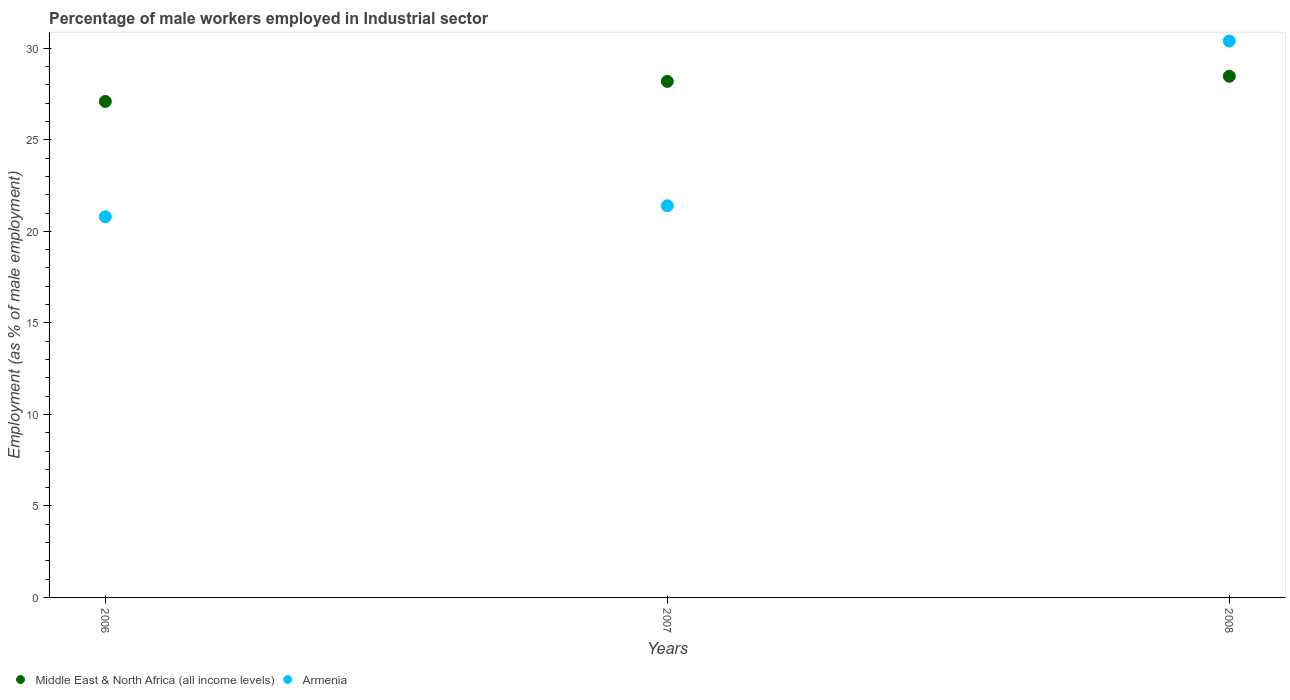What is the percentage of male workers employed in Industrial sector in Middle East & North Africa (all income levels) in 2006?
Provide a short and direct response. 27.1. Across all years, what is the maximum percentage of male workers employed in Industrial sector in Middle East & North Africa (all income levels)?
Your response must be concise. 28.47. Across all years, what is the minimum percentage of male workers employed in Industrial sector in Middle East & North Africa (all income levels)?
Provide a succinct answer. 27.1. In which year was the percentage of male workers employed in Industrial sector in Armenia maximum?
Ensure brevity in your answer.  2008. In which year was the percentage of male workers employed in Industrial sector in Armenia minimum?
Provide a short and direct response. 2006. What is the total percentage of male workers employed in Industrial sector in Armenia in the graph?
Keep it short and to the point. 72.6. What is the difference between the percentage of male workers employed in Industrial sector in Armenia in 2006 and that in 2007?
Make the answer very short. -0.6. What is the difference between the percentage of male workers employed in Industrial sector in Middle East & North Africa (all income levels) in 2006 and the percentage of male workers employed in Industrial sector in Armenia in 2007?
Offer a terse response. 5.7. What is the average percentage of male workers employed in Industrial sector in Armenia per year?
Your answer should be very brief. 24.2. In the year 2006, what is the difference between the percentage of male workers employed in Industrial sector in Armenia and percentage of male workers employed in Industrial sector in Middle East & North Africa (all income levels)?
Give a very brief answer. -6.3. What is the ratio of the percentage of male workers employed in Industrial sector in Middle East & North Africa (all income levels) in 2007 to that in 2008?
Give a very brief answer. 0.99. Is the difference between the percentage of male workers employed in Industrial sector in Armenia in 2006 and 2008 greater than the difference between the percentage of male workers employed in Industrial sector in Middle East & North Africa (all income levels) in 2006 and 2008?
Offer a very short reply. No. What is the difference between the highest and the second highest percentage of male workers employed in Industrial sector in Armenia?
Provide a short and direct response. 9. What is the difference between the highest and the lowest percentage of male workers employed in Industrial sector in Armenia?
Offer a very short reply. 9.6. Is the sum of the percentage of male workers employed in Industrial sector in Armenia in 2006 and 2008 greater than the maximum percentage of male workers employed in Industrial sector in Middle East & North Africa (all income levels) across all years?
Offer a terse response. Yes. Does the percentage of male workers employed in Industrial sector in Middle East & North Africa (all income levels) monotonically increase over the years?
Give a very brief answer. Yes. How many years are there in the graph?
Keep it short and to the point. 3. Does the graph contain grids?
Offer a very short reply. No. Where does the legend appear in the graph?
Keep it short and to the point. Bottom left. How are the legend labels stacked?
Provide a short and direct response. Horizontal. What is the title of the graph?
Your response must be concise. Percentage of male workers employed in Industrial sector. What is the label or title of the Y-axis?
Your answer should be very brief. Employment (as % of male employment). What is the Employment (as % of male employment) of Middle East & North Africa (all income levels) in 2006?
Provide a succinct answer. 27.1. What is the Employment (as % of male employment) of Armenia in 2006?
Your answer should be compact. 20.8. What is the Employment (as % of male employment) of Middle East & North Africa (all income levels) in 2007?
Your response must be concise. 28.19. What is the Employment (as % of male employment) of Armenia in 2007?
Give a very brief answer. 21.4. What is the Employment (as % of male employment) in Middle East & North Africa (all income levels) in 2008?
Make the answer very short. 28.47. What is the Employment (as % of male employment) of Armenia in 2008?
Provide a succinct answer. 30.4. Across all years, what is the maximum Employment (as % of male employment) of Middle East & North Africa (all income levels)?
Your response must be concise. 28.47. Across all years, what is the maximum Employment (as % of male employment) in Armenia?
Offer a terse response. 30.4. Across all years, what is the minimum Employment (as % of male employment) in Middle East & North Africa (all income levels)?
Ensure brevity in your answer.  27.1. Across all years, what is the minimum Employment (as % of male employment) of Armenia?
Ensure brevity in your answer.  20.8. What is the total Employment (as % of male employment) in Middle East & North Africa (all income levels) in the graph?
Your answer should be very brief. 83.77. What is the total Employment (as % of male employment) of Armenia in the graph?
Your answer should be very brief. 72.6. What is the difference between the Employment (as % of male employment) of Middle East & North Africa (all income levels) in 2006 and that in 2007?
Your answer should be very brief. -1.1. What is the difference between the Employment (as % of male employment) of Armenia in 2006 and that in 2007?
Offer a very short reply. -0.6. What is the difference between the Employment (as % of male employment) in Middle East & North Africa (all income levels) in 2006 and that in 2008?
Your answer should be compact. -1.38. What is the difference between the Employment (as % of male employment) of Middle East & North Africa (all income levels) in 2007 and that in 2008?
Keep it short and to the point. -0.28. What is the difference between the Employment (as % of male employment) in Middle East & North Africa (all income levels) in 2006 and the Employment (as % of male employment) in Armenia in 2007?
Make the answer very short. 5.7. What is the difference between the Employment (as % of male employment) of Middle East & North Africa (all income levels) in 2006 and the Employment (as % of male employment) of Armenia in 2008?
Offer a very short reply. -3.3. What is the difference between the Employment (as % of male employment) in Middle East & North Africa (all income levels) in 2007 and the Employment (as % of male employment) in Armenia in 2008?
Make the answer very short. -2.21. What is the average Employment (as % of male employment) in Middle East & North Africa (all income levels) per year?
Ensure brevity in your answer.  27.92. What is the average Employment (as % of male employment) of Armenia per year?
Provide a short and direct response. 24.2. In the year 2006, what is the difference between the Employment (as % of male employment) of Middle East & North Africa (all income levels) and Employment (as % of male employment) of Armenia?
Keep it short and to the point. 6.3. In the year 2007, what is the difference between the Employment (as % of male employment) in Middle East & North Africa (all income levels) and Employment (as % of male employment) in Armenia?
Your answer should be compact. 6.79. In the year 2008, what is the difference between the Employment (as % of male employment) of Middle East & North Africa (all income levels) and Employment (as % of male employment) of Armenia?
Give a very brief answer. -1.93. What is the ratio of the Employment (as % of male employment) in Middle East & North Africa (all income levels) in 2006 to that in 2007?
Keep it short and to the point. 0.96. What is the ratio of the Employment (as % of male employment) in Middle East & North Africa (all income levels) in 2006 to that in 2008?
Offer a very short reply. 0.95. What is the ratio of the Employment (as % of male employment) in Armenia in 2006 to that in 2008?
Offer a very short reply. 0.68. What is the ratio of the Employment (as % of male employment) in Middle East & North Africa (all income levels) in 2007 to that in 2008?
Offer a terse response. 0.99. What is the ratio of the Employment (as % of male employment) in Armenia in 2007 to that in 2008?
Give a very brief answer. 0.7. What is the difference between the highest and the second highest Employment (as % of male employment) in Middle East & North Africa (all income levels)?
Keep it short and to the point. 0.28. What is the difference between the highest and the lowest Employment (as % of male employment) of Middle East & North Africa (all income levels)?
Ensure brevity in your answer.  1.38. What is the difference between the highest and the lowest Employment (as % of male employment) in Armenia?
Give a very brief answer. 9.6. 